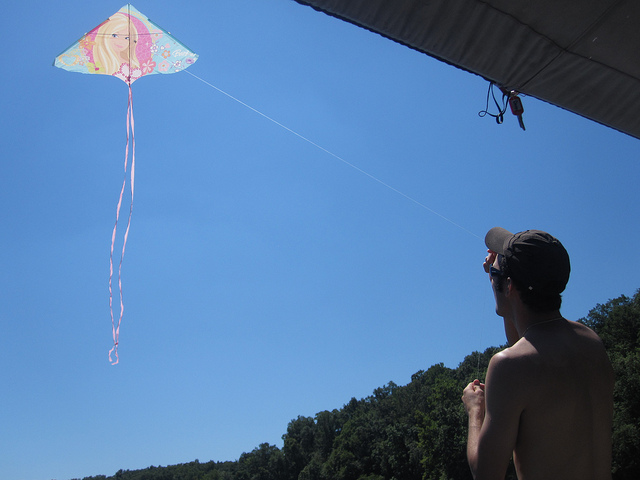How many kites are in the sky? 1 